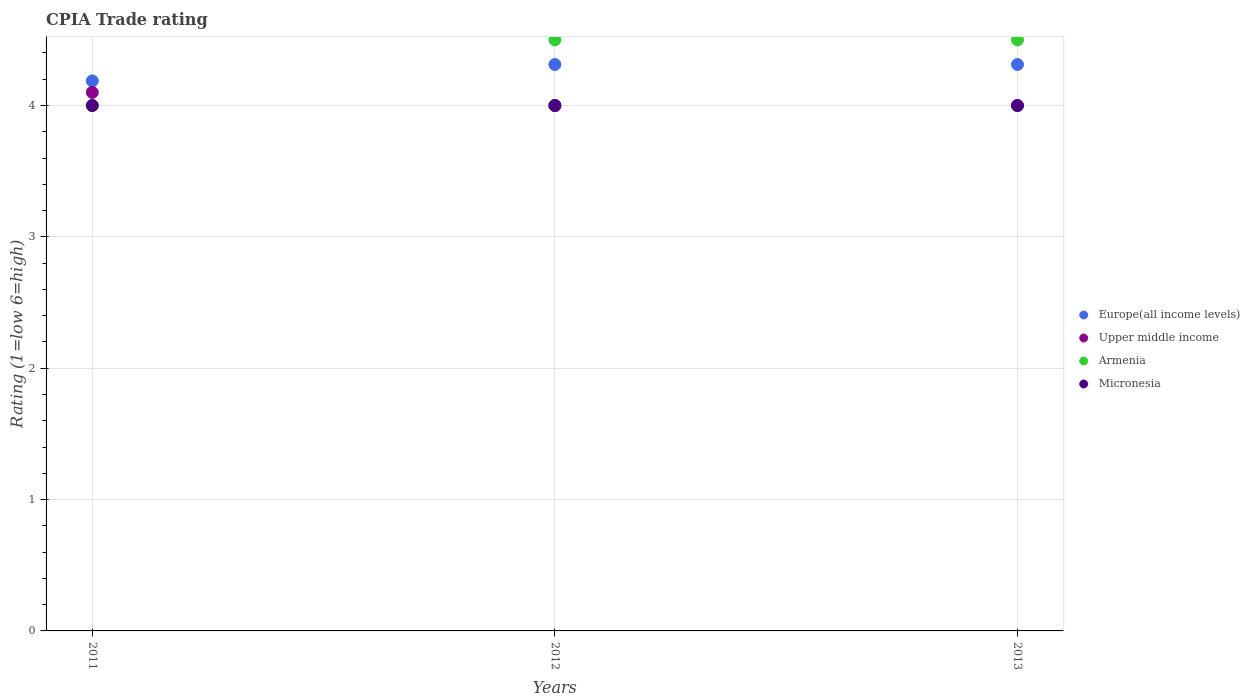Is the number of dotlines equal to the number of legend labels?
Give a very brief answer. Yes. What is the CPIA rating in Europe(all income levels) in 2011?
Provide a succinct answer. 4.19. Across all years, what is the minimum CPIA rating in Europe(all income levels)?
Keep it short and to the point. 4.19. In which year was the CPIA rating in Upper middle income maximum?
Your response must be concise. 2011. In which year was the CPIA rating in Europe(all income levels) minimum?
Your answer should be compact. 2011. What is the total CPIA rating in Europe(all income levels) in the graph?
Your answer should be very brief. 12.81. What is the difference between the CPIA rating in Micronesia in 2012 and that in 2013?
Offer a terse response. 0. What is the difference between the CPIA rating in Armenia in 2013 and the CPIA rating in Upper middle income in 2012?
Make the answer very short. 0.5. What is the average CPIA rating in Europe(all income levels) per year?
Keep it short and to the point. 4.27. In the year 2011, what is the difference between the CPIA rating in Europe(all income levels) and CPIA rating in Armenia?
Make the answer very short. 0.19. In how many years, is the CPIA rating in Armenia greater than 1.8?
Make the answer very short. 3. What is the ratio of the CPIA rating in Europe(all income levels) in 2012 to that in 2013?
Keep it short and to the point. 1. Is the difference between the CPIA rating in Europe(all income levels) in 2012 and 2013 greater than the difference between the CPIA rating in Armenia in 2012 and 2013?
Offer a terse response. No. What is the difference between the highest and the second highest CPIA rating in Upper middle income?
Make the answer very short. 0.1. In how many years, is the CPIA rating in Micronesia greater than the average CPIA rating in Micronesia taken over all years?
Your answer should be compact. 0. Is the sum of the CPIA rating in Armenia in 2011 and 2012 greater than the maximum CPIA rating in Europe(all income levels) across all years?
Your answer should be very brief. Yes. Is it the case that in every year, the sum of the CPIA rating in Europe(all income levels) and CPIA rating in Armenia  is greater than the CPIA rating in Micronesia?
Your answer should be very brief. Yes. Does the CPIA rating in Europe(all income levels) monotonically increase over the years?
Your answer should be compact. No. How many dotlines are there?
Offer a very short reply. 4. How many years are there in the graph?
Make the answer very short. 3. Are the values on the major ticks of Y-axis written in scientific E-notation?
Your answer should be compact. No. Does the graph contain grids?
Your answer should be compact. Yes. What is the title of the graph?
Keep it short and to the point. CPIA Trade rating. Does "Burundi" appear as one of the legend labels in the graph?
Your answer should be compact. No. What is the label or title of the Y-axis?
Offer a very short reply. Rating (1=low 6=high). What is the Rating (1=low 6=high) in Europe(all income levels) in 2011?
Give a very brief answer. 4.19. What is the Rating (1=low 6=high) in Micronesia in 2011?
Offer a very short reply. 4. What is the Rating (1=low 6=high) of Europe(all income levels) in 2012?
Offer a terse response. 4.31. What is the Rating (1=low 6=high) in Micronesia in 2012?
Ensure brevity in your answer.  4. What is the Rating (1=low 6=high) in Europe(all income levels) in 2013?
Your answer should be very brief. 4.31. What is the Rating (1=low 6=high) of Upper middle income in 2013?
Offer a terse response. 4. What is the Rating (1=low 6=high) in Micronesia in 2013?
Keep it short and to the point. 4. Across all years, what is the maximum Rating (1=low 6=high) of Europe(all income levels)?
Your answer should be compact. 4.31. Across all years, what is the maximum Rating (1=low 6=high) in Upper middle income?
Keep it short and to the point. 4.1. Across all years, what is the maximum Rating (1=low 6=high) of Armenia?
Make the answer very short. 4.5. Across all years, what is the minimum Rating (1=low 6=high) of Europe(all income levels)?
Keep it short and to the point. 4.19. What is the total Rating (1=low 6=high) of Europe(all income levels) in the graph?
Your response must be concise. 12.81. What is the total Rating (1=low 6=high) in Upper middle income in the graph?
Provide a succinct answer. 12.1. What is the total Rating (1=low 6=high) of Micronesia in the graph?
Ensure brevity in your answer.  12. What is the difference between the Rating (1=low 6=high) of Europe(all income levels) in 2011 and that in 2012?
Ensure brevity in your answer.  -0.12. What is the difference between the Rating (1=low 6=high) of Europe(all income levels) in 2011 and that in 2013?
Your response must be concise. -0.12. What is the difference between the Rating (1=low 6=high) of Armenia in 2011 and that in 2013?
Offer a terse response. -0.5. What is the difference between the Rating (1=low 6=high) of Micronesia in 2011 and that in 2013?
Your response must be concise. 0. What is the difference between the Rating (1=low 6=high) of Micronesia in 2012 and that in 2013?
Ensure brevity in your answer.  0. What is the difference between the Rating (1=low 6=high) in Europe(all income levels) in 2011 and the Rating (1=low 6=high) in Upper middle income in 2012?
Your answer should be very brief. 0.19. What is the difference between the Rating (1=low 6=high) of Europe(all income levels) in 2011 and the Rating (1=low 6=high) of Armenia in 2012?
Offer a very short reply. -0.31. What is the difference between the Rating (1=low 6=high) in Europe(all income levels) in 2011 and the Rating (1=low 6=high) in Micronesia in 2012?
Your answer should be compact. 0.19. What is the difference between the Rating (1=low 6=high) of Armenia in 2011 and the Rating (1=low 6=high) of Micronesia in 2012?
Offer a very short reply. 0. What is the difference between the Rating (1=low 6=high) in Europe(all income levels) in 2011 and the Rating (1=low 6=high) in Upper middle income in 2013?
Your response must be concise. 0.19. What is the difference between the Rating (1=low 6=high) in Europe(all income levels) in 2011 and the Rating (1=low 6=high) in Armenia in 2013?
Ensure brevity in your answer.  -0.31. What is the difference between the Rating (1=low 6=high) in Europe(all income levels) in 2011 and the Rating (1=low 6=high) in Micronesia in 2013?
Provide a succinct answer. 0.19. What is the difference between the Rating (1=low 6=high) in Upper middle income in 2011 and the Rating (1=low 6=high) in Armenia in 2013?
Ensure brevity in your answer.  -0.4. What is the difference between the Rating (1=low 6=high) of Upper middle income in 2011 and the Rating (1=low 6=high) of Micronesia in 2013?
Provide a short and direct response. 0.1. What is the difference between the Rating (1=low 6=high) in Europe(all income levels) in 2012 and the Rating (1=low 6=high) in Upper middle income in 2013?
Make the answer very short. 0.31. What is the difference between the Rating (1=low 6=high) of Europe(all income levels) in 2012 and the Rating (1=low 6=high) of Armenia in 2013?
Give a very brief answer. -0.19. What is the difference between the Rating (1=low 6=high) of Europe(all income levels) in 2012 and the Rating (1=low 6=high) of Micronesia in 2013?
Give a very brief answer. 0.31. What is the difference between the Rating (1=low 6=high) in Upper middle income in 2012 and the Rating (1=low 6=high) in Armenia in 2013?
Ensure brevity in your answer.  -0.5. What is the difference between the Rating (1=low 6=high) in Upper middle income in 2012 and the Rating (1=low 6=high) in Micronesia in 2013?
Ensure brevity in your answer.  0. What is the average Rating (1=low 6=high) in Europe(all income levels) per year?
Offer a terse response. 4.27. What is the average Rating (1=low 6=high) in Upper middle income per year?
Your response must be concise. 4.03. What is the average Rating (1=low 6=high) of Armenia per year?
Offer a very short reply. 4.33. In the year 2011, what is the difference between the Rating (1=low 6=high) of Europe(all income levels) and Rating (1=low 6=high) of Upper middle income?
Give a very brief answer. 0.09. In the year 2011, what is the difference between the Rating (1=low 6=high) of Europe(all income levels) and Rating (1=low 6=high) of Armenia?
Offer a very short reply. 0.19. In the year 2011, what is the difference between the Rating (1=low 6=high) in Europe(all income levels) and Rating (1=low 6=high) in Micronesia?
Provide a succinct answer. 0.19. In the year 2011, what is the difference between the Rating (1=low 6=high) of Upper middle income and Rating (1=low 6=high) of Armenia?
Keep it short and to the point. 0.1. In the year 2011, what is the difference between the Rating (1=low 6=high) in Upper middle income and Rating (1=low 6=high) in Micronesia?
Give a very brief answer. 0.1. In the year 2012, what is the difference between the Rating (1=low 6=high) of Europe(all income levels) and Rating (1=low 6=high) of Upper middle income?
Provide a succinct answer. 0.31. In the year 2012, what is the difference between the Rating (1=low 6=high) in Europe(all income levels) and Rating (1=low 6=high) in Armenia?
Your response must be concise. -0.19. In the year 2012, what is the difference between the Rating (1=low 6=high) in Europe(all income levels) and Rating (1=low 6=high) in Micronesia?
Offer a very short reply. 0.31. In the year 2012, what is the difference between the Rating (1=low 6=high) of Upper middle income and Rating (1=low 6=high) of Armenia?
Offer a very short reply. -0.5. In the year 2013, what is the difference between the Rating (1=low 6=high) of Europe(all income levels) and Rating (1=low 6=high) of Upper middle income?
Your response must be concise. 0.31. In the year 2013, what is the difference between the Rating (1=low 6=high) of Europe(all income levels) and Rating (1=low 6=high) of Armenia?
Offer a very short reply. -0.19. In the year 2013, what is the difference between the Rating (1=low 6=high) in Europe(all income levels) and Rating (1=low 6=high) in Micronesia?
Keep it short and to the point. 0.31. In the year 2013, what is the difference between the Rating (1=low 6=high) in Upper middle income and Rating (1=low 6=high) in Armenia?
Provide a short and direct response. -0.5. In the year 2013, what is the difference between the Rating (1=low 6=high) of Upper middle income and Rating (1=low 6=high) of Micronesia?
Give a very brief answer. 0. What is the ratio of the Rating (1=low 6=high) of Armenia in 2011 to that in 2012?
Ensure brevity in your answer.  0.89. What is the ratio of the Rating (1=low 6=high) of Upper middle income in 2011 to that in 2013?
Provide a succinct answer. 1.02. What is the ratio of the Rating (1=low 6=high) of Micronesia in 2011 to that in 2013?
Make the answer very short. 1. What is the ratio of the Rating (1=low 6=high) of Europe(all income levels) in 2012 to that in 2013?
Ensure brevity in your answer.  1. What is the ratio of the Rating (1=low 6=high) of Armenia in 2012 to that in 2013?
Ensure brevity in your answer.  1. What is the ratio of the Rating (1=low 6=high) of Micronesia in 2012 to that in 2013?
Make the answer very short. 1. What is the difference between the highest and the second highest Rating (1=low 6=high) in Europe(all income levels)?
Provide a succinct answer. 0. What is the difference between the highest and the second highest Rating (1=low 6=high) in Armenia?
Offer a terse response. 0. What is the difference between the highest and the lowest Rating (1=low 6=high) in Europe(all income levels)?
Provide a succinct answer. 0.12. 